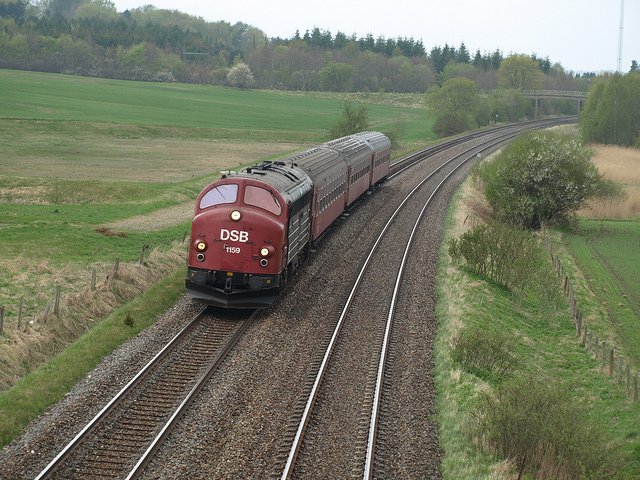What type of vehicle is shown in the image? The image shows a diesel locomotive pulling passenger cars along a railway track. Can you tell me more about this specific model? Without identifying markings or model numbers, it's difficult to provide specifics. However, by its design, it appears to be a vintage model, perhaps from the mid-20th century, characterized by its rounded nose and classic livery, typical of trains from that era. 